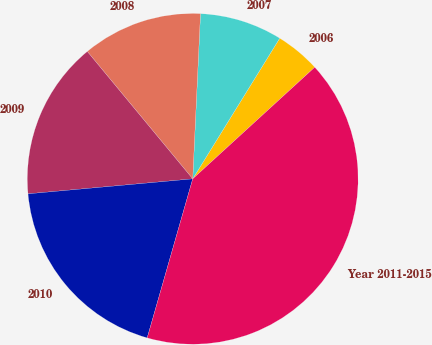<chart> <loc_0><loc_0><loc_500><loc_500><pie_chart><fcel>2006<fcel>2007<fcel>2008<fcel>2009<fcel>2010<fcel>Year 2011-2015<nl><fcel>4.39%<fcel>8.07%<fcel>11.75%<fcel>15.44%<fcel>19.12%<fcel>41.23%<nl></chart> 